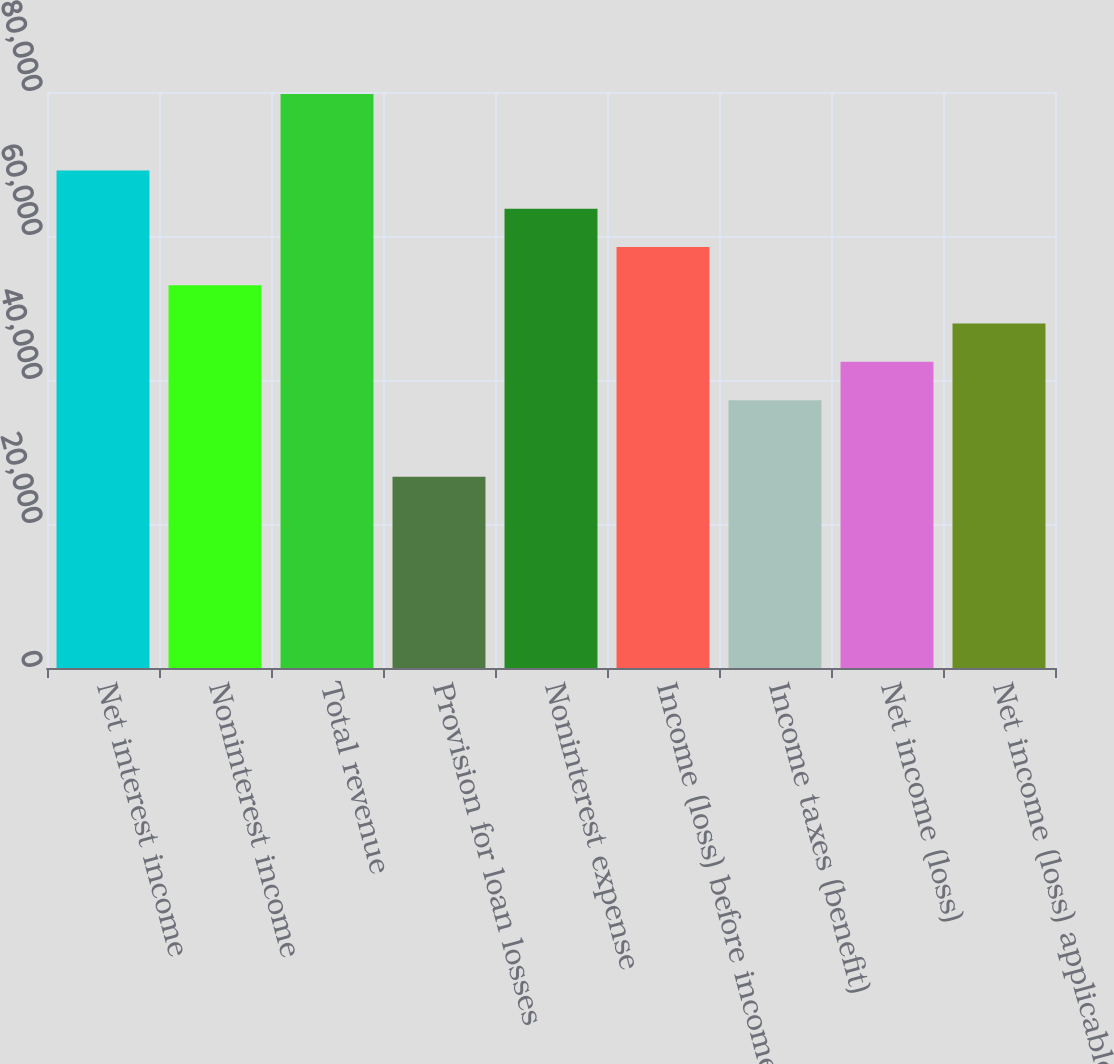Convert chart to OTSL. <chart><loc_0><loc_0><loc_500><loc_500><bar_chart><fcel>Net interest income<fcel>Noninterest income<fcel>Total revenue<fcel>Provision for loan losses<fcel>Noninterest expense<fcel>Income (loss) before income<fcel>Income taxes (benefit)<fcel>Net income (loss)<fcel>Net income (loss) applicable<nl><fcel>69093.7<fcel>53149<fcel>79723.5<fcel>26574.5<fcel>63778.8<fcel>58463.9<fcel>37204.3<fcel>42519.2<fcel>47834.1<nl></chart> 